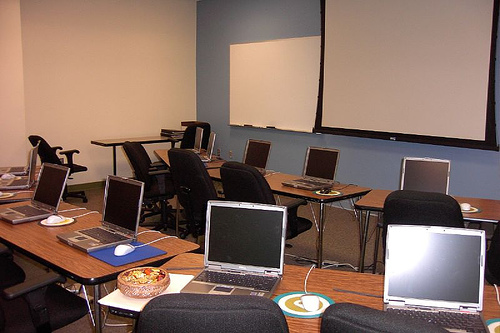Is the projector in this room currently on or off? The projector screen in the image is blank, suggesting that the projector is currently off, or that it hasn't been connected to a laptop yet to display anything. 